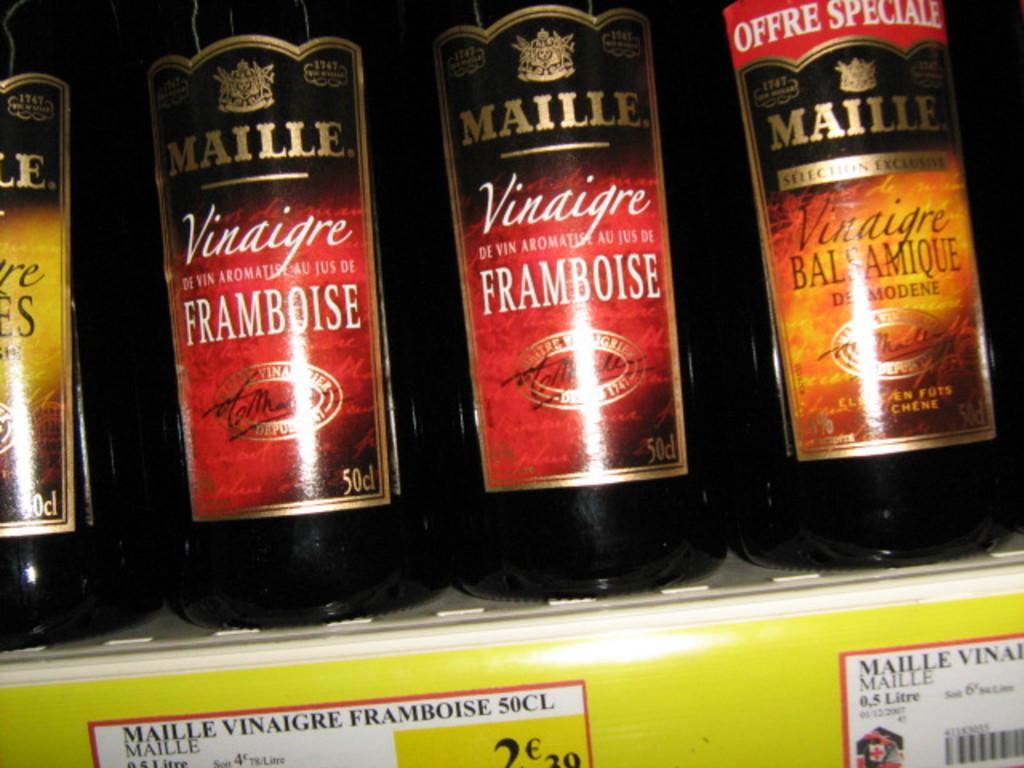Describe this image in one or two sentences. In this image I can see a white colored rack and in the rack I can see few black colored bottles and few stickers attached to them which are red, black and yellow in color. I can see a yellow colored board and few papers attached to it. 